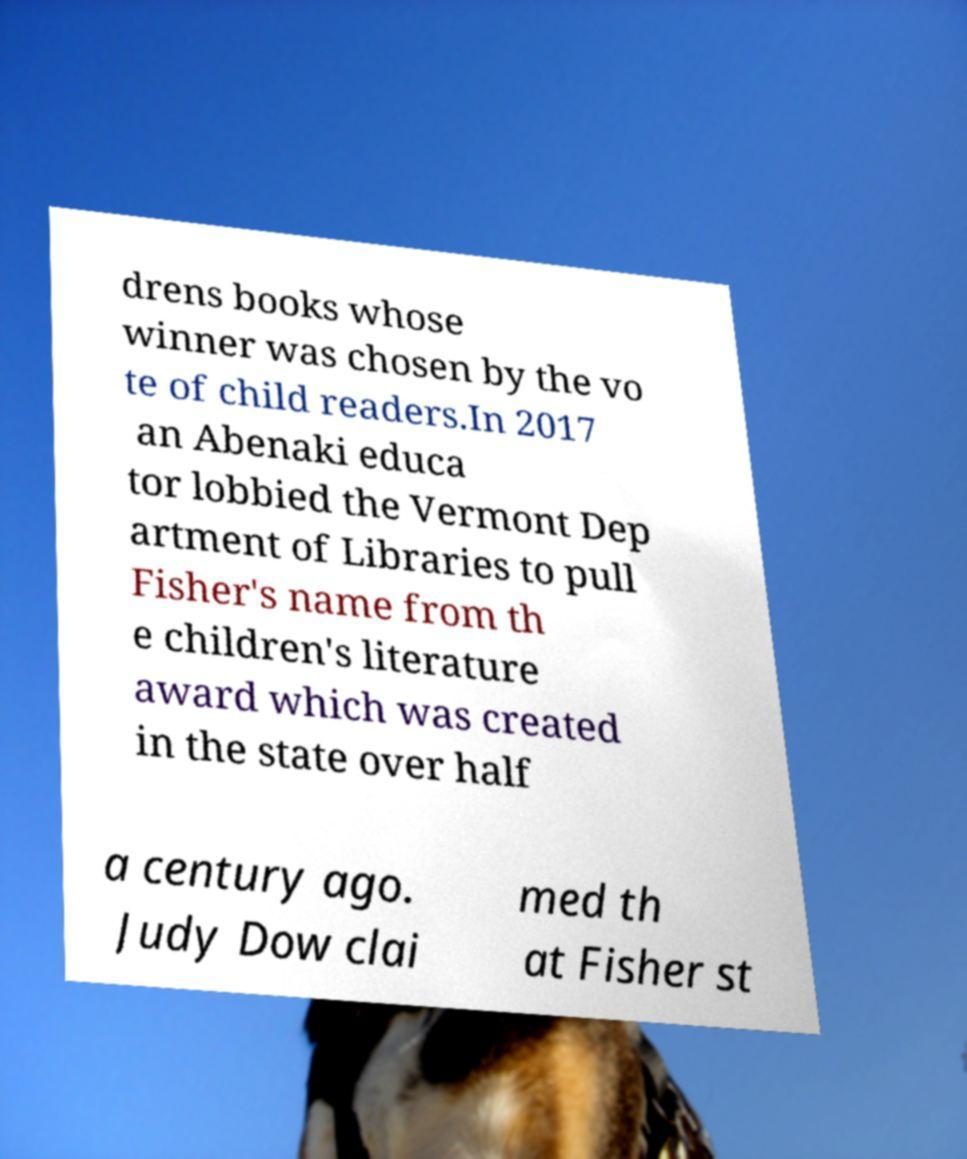Could you extract and type out the text from this image? drens books whose winner was chosen by the vo te of child readers.In 2017 an Abenaki educa tor lobbied the Vermont Dep artment of Libraries to pull Fisher's name from th e children's literature award which was created in the state over half a century ago. Judy Dow clai med th at Fisher st 